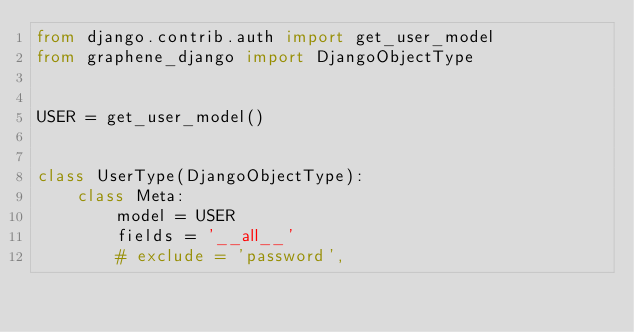Convert code to text. <code><loc_0><loc_0><loc_500><loc_500><_Python_>from django.contrib.auth import get_user_model
from graphene_django import DjangoObjectType


USER = get_user_model()


class UserType(DjangoObjectType):
    class Meta:
        model = USER
        fields = '__all__'
        # exclude = 'password',
</code> 